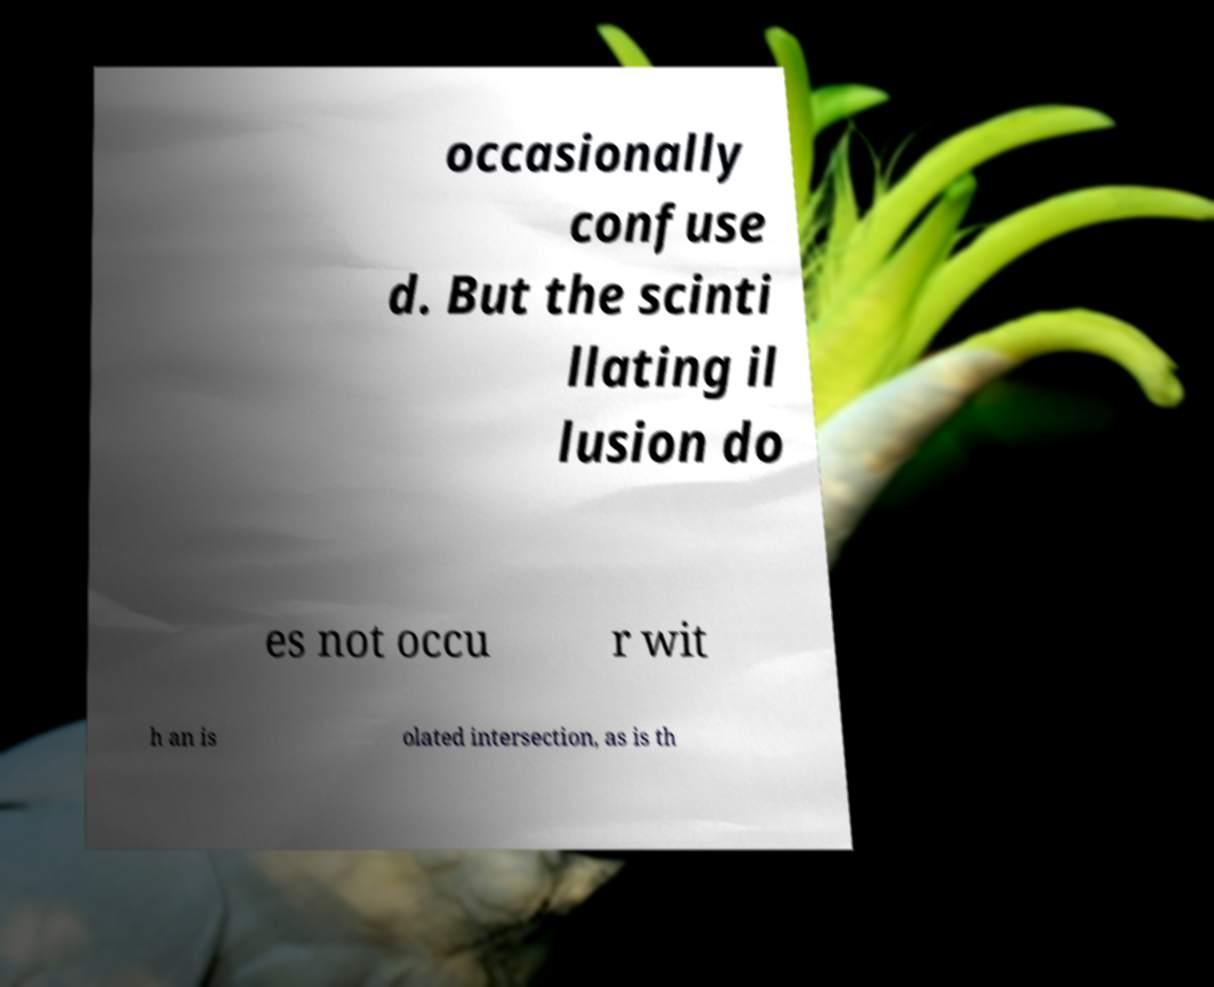Could you extract and type out the text from this image? occasionally confuse d. But the scinti llating il lusion do es not occu r wit h an is olated intersection, as is th 